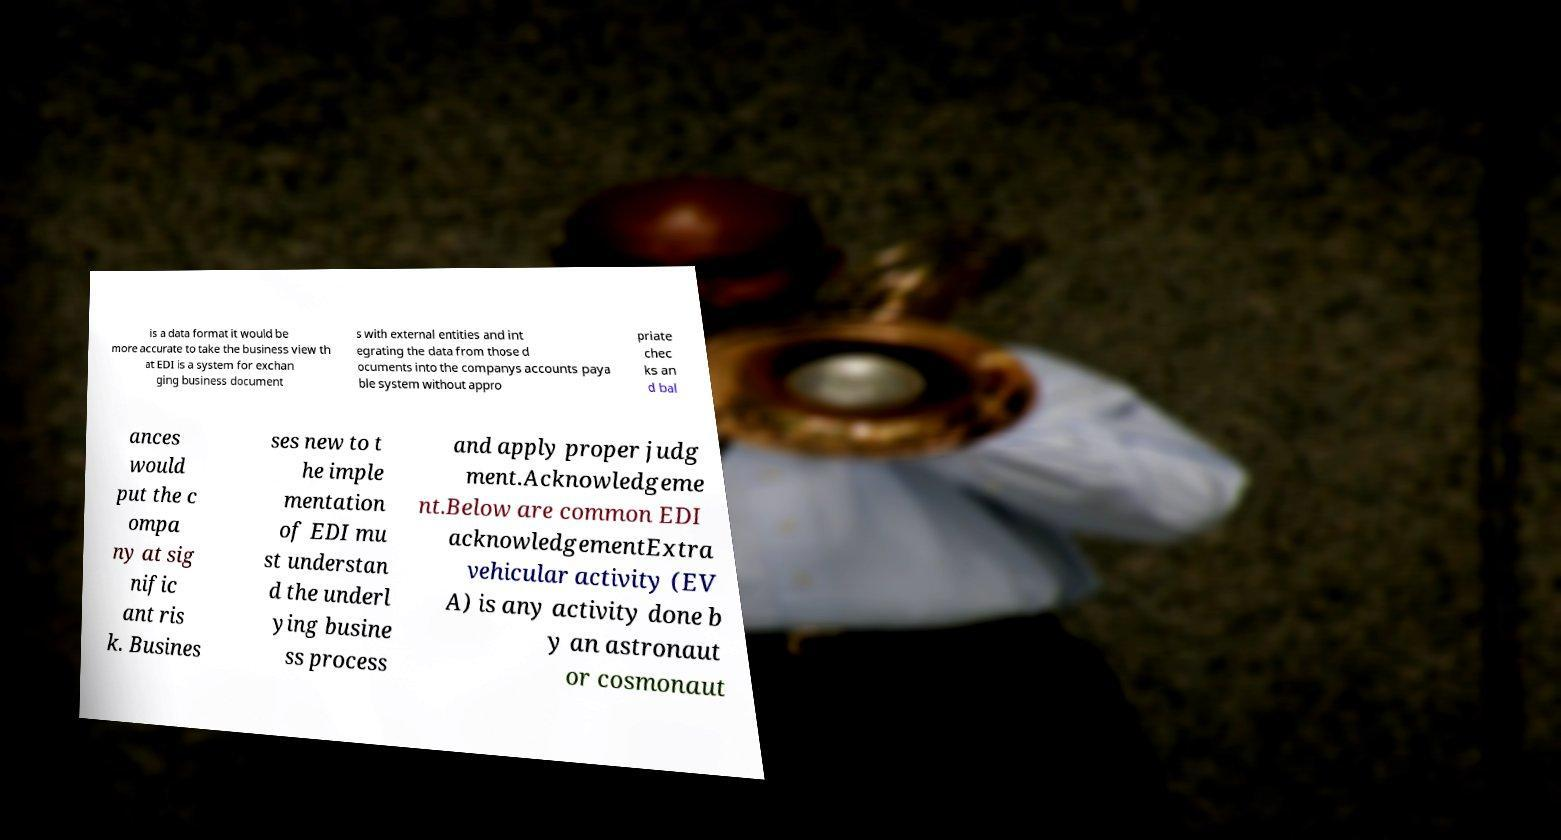What messages or text are displayed in this image? I need them in a readable, typed format. is a data format it would be more accurate to take the business view th at EDI is a system for exchan ging business document s with external entities and int egrating the data from those d ocuments into the companys accounts paya ble system without appro priate chec ks an d bal ances would put the c ompa ny at sig nific ant ris k. Busines ses new to t he imple mentation of EDI mu st understan d the underl ying busine ss process and apply proper judg ment.Acknowledgeme nt.Below are common EDI acknowledgementExtra vehicular activity (EV A) is any activity done b y an astronaut or cosmonaut 